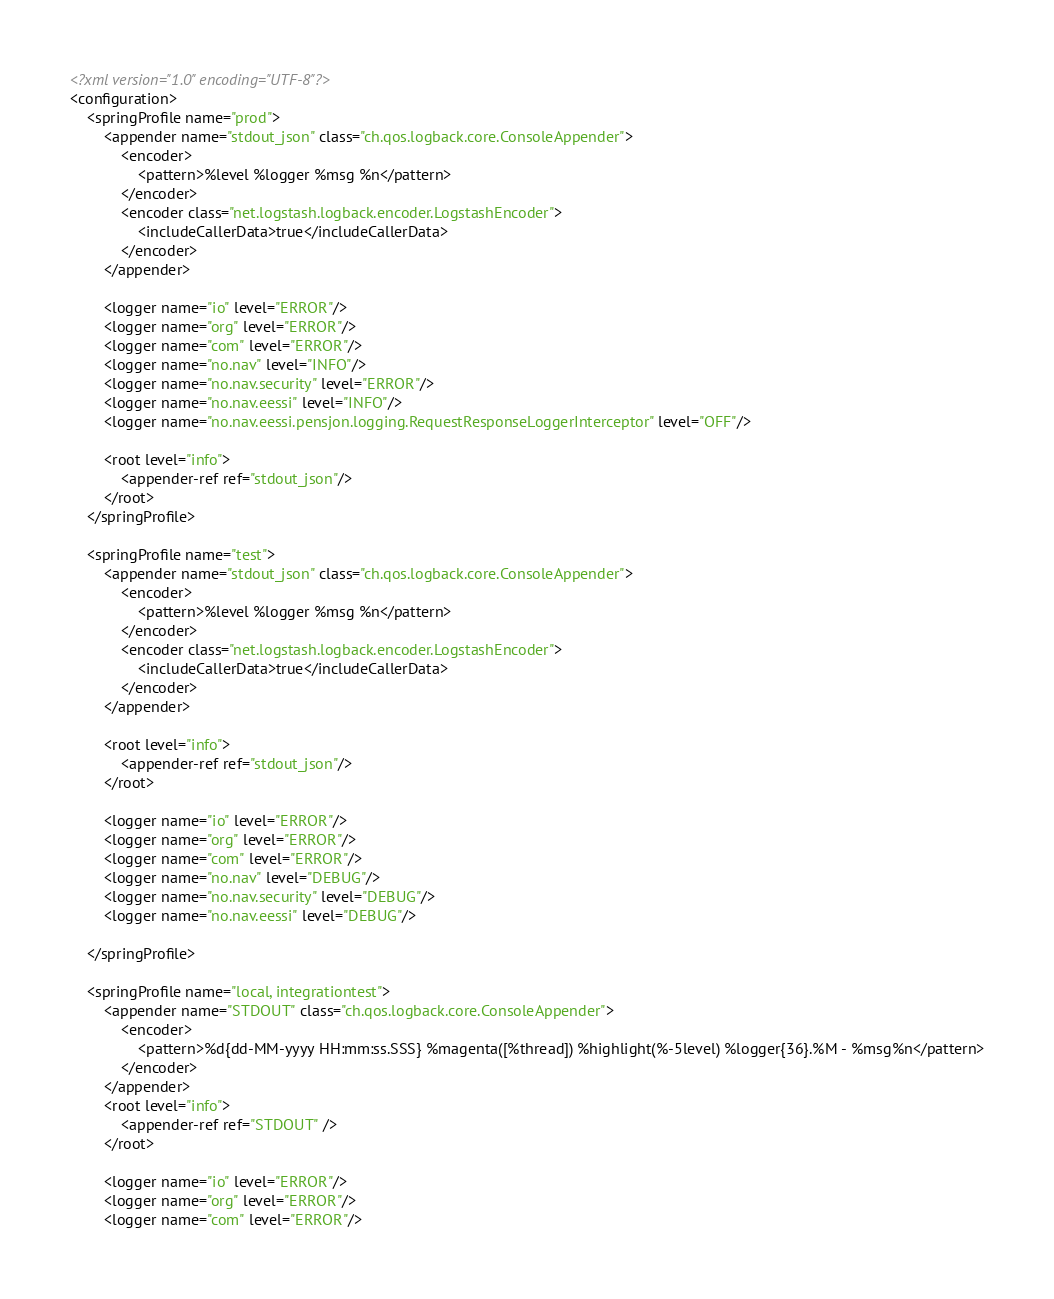<code> <loc_0><loc_0><loc_500><loc_500><_XML_><?xml version="1.0" encoding="UTF-8"?>
<configuration>
    <springProfile name="prod">
        <appender name="stdout_json" class="ch.qos.logback.core.ConsoleAppender">
            <encoder>
                <pattern>%level %logger %msg %n</pattern>
            </encoder>
            <encoder class="net.logstash.logback.encoder.LogstashEncoder">
                <includeCallerData>true</includeCallerData>
            </encoder>
        </appender>

        <logger name="io" level="ERROR"/>
        <logger name="org" level="ERROR"/>
        <logger name="com" level="ERROR"/>
        <logger name="no.nav" level="INFO"/>
        <logger name="no.nav.security" level="ERROR"/>
        <logger name="no.nav.eessi" level="INFO"/>
        <logger name="no.nav.eessi.pensjon.logging.RequestResponseLoggerInterceptor" level="OFF"/>

        <root level="info">
            <appender-ref ref="stdout_json"/>
        </root>
    </springProfile>

    <springProfile name="test">
        <appender name="stdout_json" class="ch.qos.logback.core.ConsoleAppender">
            <encoder>
                <pattern>%level %logger %msg %n</pattern>
            </encoder>
            <encoder class="net.logstash.logback.encoder.LogstashEncoder">
                <includeCallerData>true</includeCallerData>
            </encoder>
        </appender>

        <root level="info">
            <appender-ref ref="stdout_json"/>
        </root>

        <logger name="io" level="ERROR"/>
        <logger name="org" level="ERROR"/>
        <logger name="com" level="ERROR"/>
        <logger name="no.nav" level="DEBUG"/>
        <logger name="no.nav.security" level="DEBUG"/>
        <logger name="no.nav.eessi" level="DEBUG"/>

    </springProfile>

    <springProfile name="local, integrationtest">
        <appender name="STDOUT" class="ch.qos.logback.core.ConsoleAppender">
            <encoder>
                <pattern>%d{dd-MM-yyyy HH:mm:ss.SSS} %magenta([%thread]) %highlight(%-5level) %logger{36}.%M - %msg%n</pattern>
            </encoder>
        </appender>
        <root level="info">
            <appender-ref ref="STDOUT" />
        </root>

        <logger name="io" level="ERROR"/>
        <logger name="org" level="ERROR"/>
        <logger name="com" level="ERROR"/></code> 